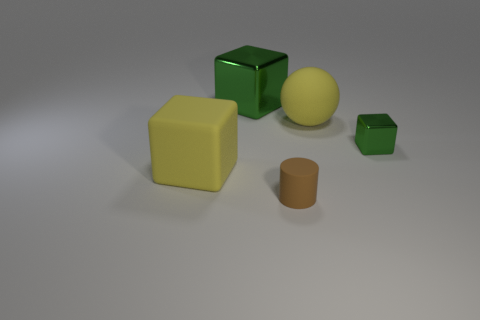Is there any other thing that has the same shape as the small matte thing?
Your answer should be very brief. No. Do the small object that is on the right side of the tiny brown object and the small brown object have the same material?
Provide a succinct answer. No. How many yellow matte blocks have the same size as the yellow rubber sphere?
Offer a terse response. 1. Are there more large green things that are in front of the rubber sphere than yellow rubber objects that are behind the large metallic cube?
Keep it short and to the point. No. Are there any other things of the same shape as the tiny green metal object?
Make the answer very short. Yes. There is a thing on the right side of the big matte object that is on the right side of the big green thing; what is its size?
Give a very brief answer. Small. There is a tiny object that is on the left side of the large yellow matte thing that is behind the big block that is in front of the big yellow matte sphere; what is its shape?
Provide a succinct answer. Cylinder. The yellow cube that is made of the same material as the large sphere is what size?
Give a very brief answer. Large. Is the number of big metallic cubes greater than the number of shiny things?
Give a very brief answer. No. What is the material of the green object that is the same size as the yellow sphere?
Your response must be concise. Metal. 